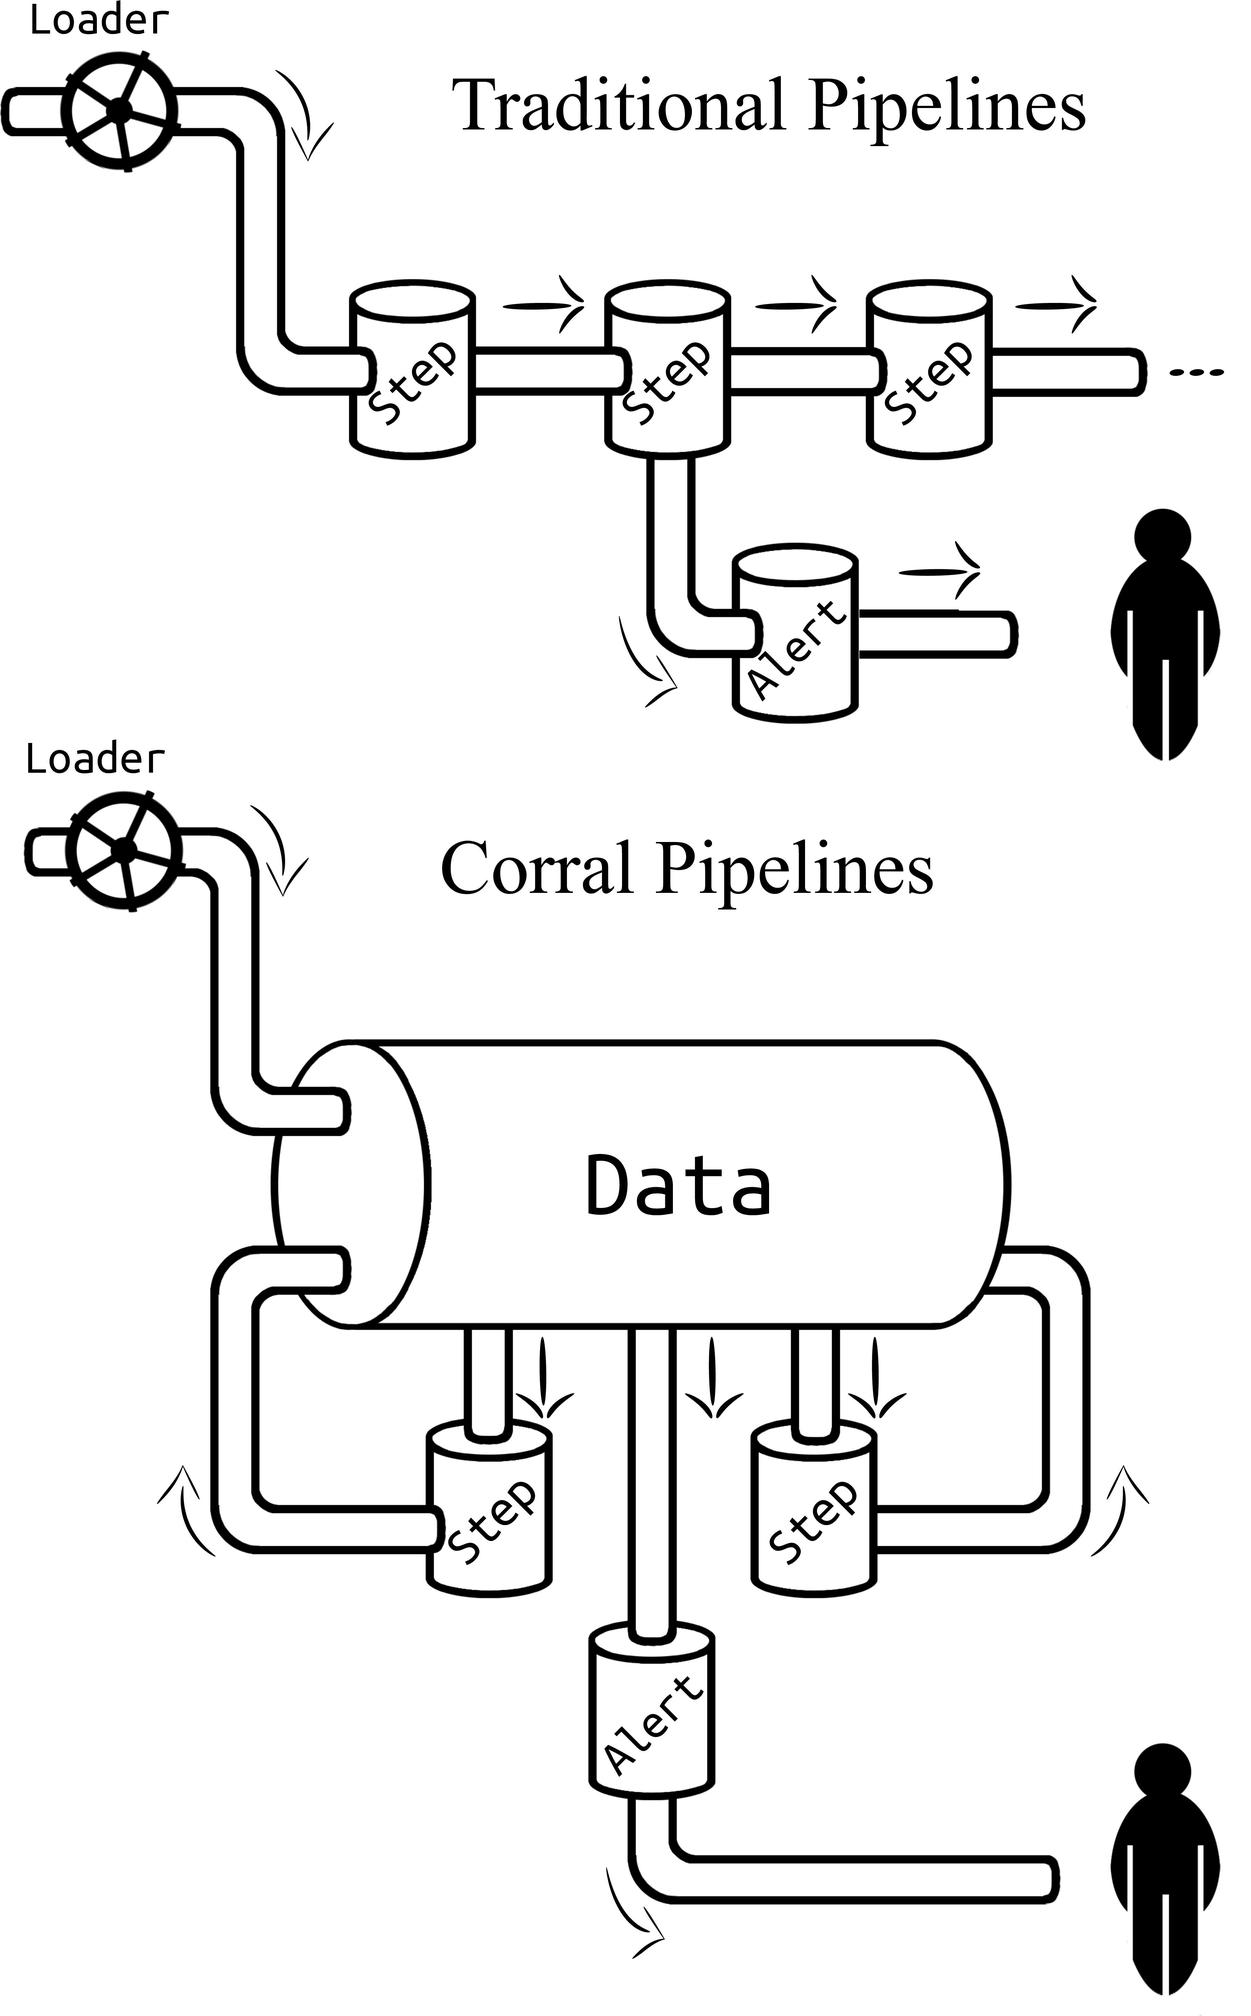What is the function of the "Alert" component in the pipelines? The 'Alert' component in the pipelines, as depicted in the diagrams, serves a crucial role in monitoring the data processing workflow. Situated at strategic junctures, it functions as a sentinel that supervises the flow of data through each step. Upon encountering anomalies, errors, or specific conditions predefined by the system's requirements, this component triggers notifications to appropriate personnel or systems. This can be instrumental in ensuring the integrity and smooth operation of the pipeline, allowing for immediate response and rectification of issues. Not only does it enhance operational efficiency by prompting timely interventions, but it also provides an audit trail for system performance and error-handling efficacy, which is invaluable for maintenance and optimization tasks. 